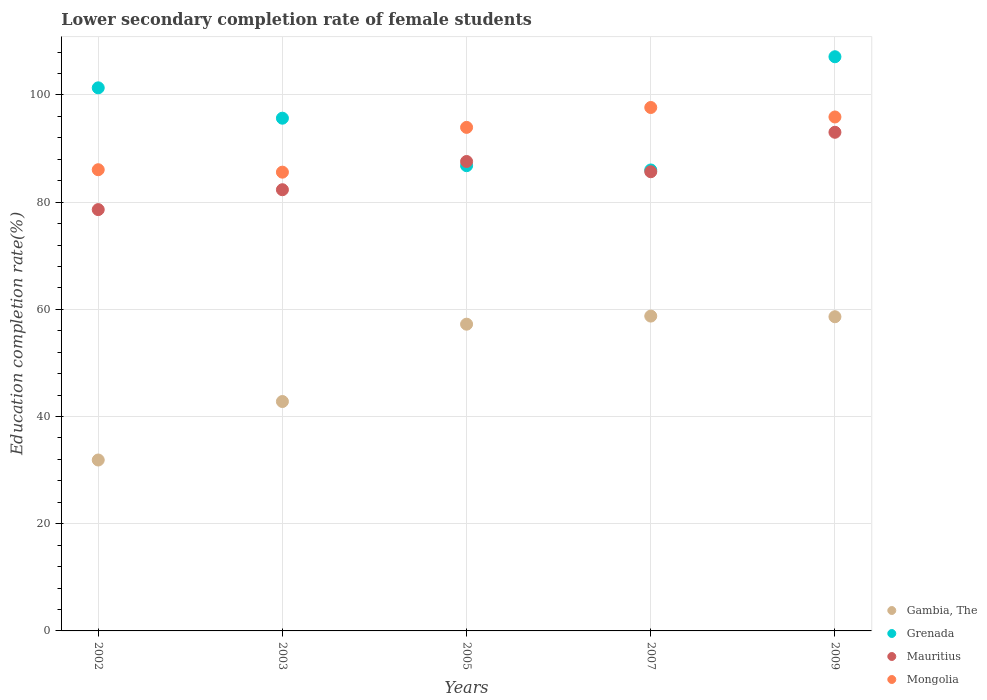How many different coloured dotlines are there?
Your answer should be compact. 4. What is the lower secondary completion rate of female students in Mongolia in 2009?
Your answer should be very brief. 95.9. Across all years, what is the maximum lower secondary completion rate of female students in Mongolia?
Offer a terse response. 97.67. Across all years, what is the minimum lower secondary completion rate of female students in Gambia, The?
Ensure brevity in your answer.  31.89. What is the total lower secondary completion rate of female students in Gambia, The in the graph?
Offer a terse response. 249.3. What is the difference between the lower secondary completion rate of female students in Gambia, The in 2002 and that in 2005?
Keep it short and to the point. -25.34. What is the difference between the lower secondary completion rate of female students in Mongolia in 2003 and the lower secondary completion rate of female students in Grenada in 2005?
Keep it short and to the point. -1.21. What is the average lower secondary completion rate of female students in Gambia, The per year?
Your answer should be very brief. 49.86. In the year 2005, what is the difference between the lower secondary completion rate of female students in Grenada and lower secondary completion rate of female students in Gambia, The?
Offer a terse response. 29.57. In how many years, is the lower secondary completion rate of female students in Grenada greater than 32 %?
Ensure brevity in your answer.  5. What is the ratio of the lower secondary completion rate of female students in Gambia, The in 2007 to that in 2009?
Your answer should be compact. 1. Is the lower secondary completion rate of female students in Mauritius in 2005 less than that in 2007?
Offer a terse response. No. Is the difference between the lower secondary completion rate of female students in Grenada in 2002 and 2005 greater than the difference between the lower secondary completion rate of female students in Gambia, The in 2002 and 2005?
Ensure brevity in your answer.  Yes. What is the difference between the highest and the second highest lower secondary completion rate of female students in Mongolia?
Offer a terse response. 1.77. What is the difference between the highest and the lowest lower secondary completion rate of female students in Mongolia?
Ensure brevity in your answer.  12.07. Is the sum of the lower secondary completion rate of female students in Grenada in 2003 and 2005 greater than the maximum lower secondary completion rate of female students in Gambia, The across all years?
Your answer should be very brief. Yes. Is it the case that in every year, the sum of the lower secondary completion rate of female students in Gambia, The and lower secondary completion rate of female students in Mauritius  is greater than the sum of lower secondary completion rate of female students in Mongolia and lower secondary completion rate of female students in Grenada?
Offer a terse response. Yes. Is it the case that in every year, the sum of the lower secondary completion rate of female students in Mongolia and lower secondary completion rate of female students in Mauritius  is greater than the lower secondary completion rate of female students in Grenada?
Provide a succinct answer. Yes. Does the lower secondary completion rate of female students in Mauritius monotonically increase over the years?
Your answer should be very brief. No. Is the lower secondary completion rate of female students in Grenada strictly greater than the lower secondary completion rate of female students in Mongolia over the years?
Ensure brevity in your answer.  No. How many dotlines are there?
Keep it short and to the point. 4. What is the difference between two consecutive major ticks on the Y-axis?
Your response must be concise. 20. Does the graph contain any zero values?
Offer a terse response. No. How many legend labels are there?
Keep it short and to the point. 4. What is the title of the graph?
Give a very brief answer. Lower secondary completion rate of female students. What is the label or title of the X-axis?
Keep it short and to the point. Years. What is the label or title of the Y-axis?
Give a very brief answer. Education completion rate(%). What is the Education completion rate(%) in Gambia, The in 2002?
Your answer should be very brief. 31.89. What is the Education completion rate(%) of Grenada in 2002?
Keep it short and to the point. 101.33. What is the Education completion rate(%) in Mauritius in 2002?
Provide a short and direct response. 78.61. What is the Education completion rate(%) of Mongolia in 2002?
Keep it short and to the point. 86.06. What is the Education completion rate(%) of Gambia, The in 2003?
Offer a terse response. 42.8. What is the Education completion rate(%) of Grenada in 2003?
Provide a succinct answer. 95.67. What is the Education completion rate(%) of Mauritius in 2003?
Offer a terse response. 82.32. What is the Education completion rate(%) of Mongolia in 2003?
Your answer should be very brief. 85.6. What is the Education completion rate(%) of Gambia, The in 2005?
Provide a short and direct response. 57.23. What is the Education completion rate(%) of Grenada in 2005?
Ensure brevity in your answer.  86.81. What is the Education completion rate(%) of Mauritius in 2005?
Offer a very short reply. 87.59. What is the Education completion rate(%) of Mongolia in 2005?
Your response must be concise. 93.96. What is the Education completion rate(%) in Gambia, The in 2007?
Your answer should be very brief. 58.74. What is the Education completion rate(%) of Grenada in 2007?
Give a very brief answer. 86.01. What is the Education completion rate(%) in Mauritius in 2007?
Keep it short and to the point. 85.68. What is the Education completion rate(%) in Mongolia in 2007?
Provide a succinct answer. 97.67. What is the Education completion rate(%) in Gambia, The in 2009?
Ensure brevity in your answer.  58.62. What is the Education completion rate(%) of Grenada in 2009?
Offer a very short reply. 107.14. What is the Education completion rate(%) of Mauritius in 2009?
Give a very brief answer. 93.04. What is the Education completion rate(%) in Mongolia in 2009?
Ensure brevity in your answer.  95.9. Across all years, what is the maximum Education completion rate(%) in Gambia, The?
Ensure brevity in your answer.  58.74. Across all years, what is the maximum Education completion rate(%) in Grenada?
Your answer should be compact. 107.14. Across all years, what is the maximum Education completion rate(%) in Mauritius?
Provide a short and direct response. 93.04. Across all years, what is the maximum Education completion rate(%) in Mongolia?
Offer a very short reply. 97.67. Across all years, what is the minimum Education completion rate(%) of Gambia, The?
Offer a very short reply. 31.89. Across all years, what is the minimum Education completion rate(%) of Grenada?
Offer a terse response. 86.01. Across all years, what is the minimum Education completion rate(%) in Mauritius?
Make the answer very short. 78.61. Across all years, what is the minimum Education completion rate(%) in Mongolia?
Ensure brevity in your answer.  85.6. What is the total Education completion rate(%) of Gambia, The in the graph?
Provide a short and direct response. 249.3. What is the total Education completion rate(%) of Grenada in the graph?
Ensure brevity in your answer.  476.95. What is the total Education completion rate(%) in Mauritius in the graph?
Provide a succinct answer. 427.25. What is the total Education completion rate(%) in Mongolia in the graph?
Provide a succinct answer. 459.17. What is the difference between the Education completion rate(%) of Gambia, The in 2002 and that in 2003?
Your answer should be compact. -10.91. What is the difference between the Education completion rate(%) in Grenada in 2002 and that in 2003?
Keep it short and to the point. 5.67. What is the difference between the Education completion rate(%) of Mauritius in 2002 and that in 2003?
Provide a succinct answer. -3.71. What is the difference between the Education completion rate(%) in Mongolia in 2002 and that in 2003?
Offer a terse response. 0.46. What is the difference between the Education completion rate(%) in Gambia, The in 2002 and that in 2005?
Provide a succinct answer. -25.34. What is the difference between the Education completion rate(%) in Grenada in 2002 and that in 2005?
Keep it short and to the point. 14.53. What is the difference between the Education completion rate(%) of Mauritius in 2002 and that in 2005?
Keep it short and to the point. -8.98. What is the difference between the Education completion rate(%) of Mongolia in 2002 and that in 2005?
Offer a very short reply. -7.9. What is the difference between the Education completion rate(%) in Gambia, The in 2002 and that in 2007?
Give a very brief answer. -26.85. What is the difference between the Education completion rate(%) in Grenada in 2002 and that in 2007?
Offer a very short reply. 15.33. What is the difference between the Education completion rate(%) in Mauritius in 2002 and that in 2007?
Keep it short and to the point. -7.07. What is the difference between the Education completion rate(%) of Mongolia in 2002 and that in 2007?
Keep it short and to the point. -11.61. What is the difference between the Education completion rate(%) in Gambia, The in 2002 and that in 2009?
Your response must be concise. -26.73. What is the difference between the Education completion rate(%) of Grenada in 2002 and that in 2009?
Your answer should be compact. -5.8. What is the difference between the Education completion rate(%) in Mauritius in 2002 and that in 2009?
Make the answer very short. -14.43. What is the difference between the Education completion rate(%) in Mongolia in 2002 and that in 2009?
Provide a short and direct response. -9.84. What is the difference between the Education completion rate(%) in Gambia, The in 2003 and that in 2005?
Your answer should be very brief. -14.43. What is the difference between the Education completion rate(%) of Grenada in 2003 and that in 2005?
Give a very brief answer. 8.86. What is the difference between the Education completion rate(%) of Mauritius in 2003 and that in 2005?
Your answer should be very brief. -5.27. What is the difference between the Education completion rate(%) in Mongolia in 2003 and that in 2005?
Keep it short and to the point. -8.36. What is the difference between the Education completion rate(%) in Gambia, The in 2003 and that in 2007?
Offer a very short reply. -15.94. What is the difference between the Education completion rate(%) in Grenada in 2003 and that in 2007?
Your response must be concise. 9.66. What is the difference between the Education completion rate(%) of Mauritius in 2003 and that in 2007?
Keep it short and to the point. -3.36. What is the difference between the Education completion rate(%) in Mongolia in 2003 and that in 2007?
Offer a very short reply. -12.07. What is the difference between the Education completion rate(%) in Gambia, The in 2003 and that in 2009?
Give a very brief answer. -15.82. What is the difference between the Education completion rate(%) in Grenada in 2003 and that in 2009?
Your answer should be very brief. -11.47. What is the difference between the Education completion rate(%) in Mauritius in 2003 and that in 2009?
Offer a terse response. -10.72. What is the difference between the Education completion rate(%) in Mongolia in 2003 and that in 2009?
Make the answer very short. -10.3. What is the difference between the Education completion rate(%) in Gambia, The in 2005 and that in 2007?
Give a very brief answer. -1.51. What is the difference between the Education completion rate(%) of Grenada in 2005 and that in 2007?
Ensure brevity in your answer.  0.8. What is the difference between the Education completion rate(%) in Mauritius in 2005 and that in 2007?
Offer a terse response. 1.91. What is the difference between the Education completion rate(%) in Mongolia in 2005 and that in 2007?
Make the answer very short. -3.71. What is the difference between the Education completion rate(%) of Gambia, The in 2005 and that in 2009?
Offer a terse response. -1.39. What is the difference between the Education completion rate(%) of Grenada in 2005 and that in 2009?
Your response must be concise. -20.33. What is the difference between the Education completion rate(%) in Mauritius in 2005 and that in 2009?
Ensure brevity in your answer.  -5.45. What is the difference between the Education completion rate(%) in Mongolia in 2005 and that in 2009?
Offer a very short reply. -1.94. What is the difference between the Education completion rate(%) of Gambia, The in 2007 and that in 2009?
Keep it short and to the point. 0.12. What is the difference between the Education completion rate(%) of Grenada in 2007 and that in 2009?
Give a very brief answer. -21.13. What is the difference between the Education completion rate(%) in Mauritius in 2007 and that in 2009?
Keep it short and to the point. -7.36. What is the difference between the Education completion rate(%) in Mongolia in 2007 and that in 2009?
Give a very brief answer. 1.77. What is the difference between the Education completion rate(%) of Gambia, The in 2002 and the Education completion rate(%) of Grenada in 2003?
Give a very brief answer. -63.78. What is the difference between the Education completion rate(%) of Gambia, The in 2002 and the Education completion rate(%) of Mauritius in 2003?
Provide a short and direct response. -50.43. What is the difference between the Education completion rate(%) in Gambia, The in 2002 and the Education completion rate(%) in Mongolia in 2003?
Give a very brief answer. -53.71. What is the difference between the Education completion rate(%) of Grenada in 2002 and the Education completion rate(%) of Mauritius in 2003?
Offer a terse response. 19.01. What is the difference between the Education completion rate(%) of Grenada in 2002 and the Education completion rate(%) of Mongolia in 2003?
Give a very brief answer. 15.74. What is the difference between the Education completion rate(%) of Mauritius in 2002 and the Education completion rate(%) of Mongolia in 2003?
Keep it short and to the point. -6.99. What is the difference between the Education completion rate(%) in Gambia, The in 2002 and the Education completion rate(%) in Grenada in 2005?
Provide a succinct answer. -54.92. What is the difference between the Education completion rate(%) in Gambia, The in 2002 and the Education completion rate(%) in Mauritius in 2005?
Offer a terse response. -55.7. What is the difference between the Education completion rate(%) of Gambia, The in 2002 and the Education completion rate(%) of Mongolia in 2005?
Offer a very short reply. -62.06. What is the difference between the Education completion rate(%) in Grenada in 2002 and the Education completion rate(%) in Mauritius in 2005?
Offer a very short reply. 13.74. What is the difference between the Education completion rate(%) in Grenada in 2002 and the Education completion rate(%) in Mongolia in 2005?
Provide a short and direct response. 7.38. What is the difference between the Education completion rate(%) in Mauritius in 2002 and the Education completion rate(%) in Mongolia in 2005?
Provide a short and direct response. -15.34. What is the difference between the Education completion rate(%) of Gambia, The in 2002 and the Education completion rate(%) of Grenada in 2007?
Ensure brevity in your answer.  -54.12. What is the difference between the Education completion rate(%) in Gambia, The in 2002 and the Education completion rate(%) in Mauritius in 2007?
Your response must be concise. -53.79. What is the difference between the Education completion rate(%) of Gambia, The in 2002 and the Education completion rate(%) of Mongolia in 2007?
Keep it short and to the point. -65.77. What is the difference between the Education completion rate(%) of Grenada in 2002 and the Education completion rate(%) of Mauritius in 2007?
Offer a very short reply. 15.65. What is the difference between the Education completion rate(%) in Grenada in 2002 and the Education completion rate(%) in Mongolia in 2007?
Keep it short and to the point. 3.67. What is the difference between the Education completion rate(%) of Mauritius in 2002 and the Education completion rate(%) of Mongolia in 2007?
Your answer should be compact. -19.05. What is the difference between the Education completion rate(%) in Gambia, The in 2002 and the Education completion rate(%) in Grenada in 2009?
Give a very brief answer. -75.24. What is the difference between the Education completion rate(%) of Gambia, The in 2002 and the Education completion rate(%) of Mauritius in 2009?
Keep it short and to the point. -61.15. What is the difference between the Education completion rate(%) of Gambia, The in 2002 and the Education completion rate(%) of Mongolia in 2009?
Give a very brief answer. -64.01. What is the difference between the Education completion rate(%) of Grenada in 2002 and the Education completion rate(%) of Mauritius in 2009?
Make the answer very short. 8.29. What is the difference between the Education completion rate(%) of Grenada in 2002 and the Education completion rate(%) of Mongolia in 2009?
Offer a terse response. 5.44. What is the difference between the Education completion rate(%) in Mauritius in 2002 and the Education completion rate(%) in Mongolia in 2009?
Make the answer very short. -17.28. What is the difference between the Education completion rate(%) in Gambia, The in 2003 and the Education completion rate(%) in Grenada in 2005?
Provide a succinct answer. -44. What is the difference between the Education completion rate(%) in Gambia, The in 2003 and the Education completion rate(%) in Mauritius in 2005?
Your response must be concise. -44.79. What is the difference between the Education completion rate(%) in Gambia, The in 2003 and the Education completion rate(%) in Mongolia in 2005?
Your answer should be very brief. -51.15. What is the difference between the Education completion rate(%) in Grenada in 2003 and the Education completion rate(%) in Mauritius in 2005?
Offer a very short reply. 8.08. What is the difference between the Education completion rate(%) in Grenada in 2003 and the Education completion rate(%) in Mongolia in 2005?
Provide a succinct answer. 1.71. What is the difference between the Education completion rate(%) of Mauritius in 2003 and the Education completion rate(%) of Mongolia in 2005?
Give a very brief answer. -11.63. What is the difference between the Education completion rate(%) of Gambia, The in 2003 and the Education completion rate(%) of Grenada in 2007?
Keep it short and to the point. -43.21. What is the difference between the Education completion rate(%) of Gambia, The in 2003 and the Education completion rate(%) of Mauritius in 2007?
Keep it short and to the point. -42.88. What is the difference between the Education completion rate(%) of Gambia, The in 2003 and the Education completion rate(%) of Mongolia in 2007?
Ensure brevity in your answer.  -54.86. What is the difference between the Education completion rate(%) of Grenada in 2003 and the Education completion rate(%) of Mauritius in 2007?
Offer a very short reply. 9.99. What is the difference between the Education completion rate(%) of Grenada in 2003 and the Education completion rate(%) of Mongolia in 2007?
Offer a terse response. -2. What is the difference between the Education completion rate(%) of Mauritius in 2003 and the Education completion rate(%) of Mongolia in 2007?
Keep it short and to the point. -15.34. What is the difference between the Education completion rate(%) of Gambia, The in 2003 and the Education completion rate(%) of Grenada in 2009?
Provide a short and direct response. -64.33. What is the difference between the Education completion rate(%) in Gambia, The in 2003 and the Education completion rate(%) in Mauritius in 2009?
Offer a very short reply. -50.24. What is the difference between the Education completion rate(%) in Gambia, The in 2003 and the Education completion rate(%) in Mongolia in 2009?
Provide a short and direct response. -53.09. What is the difference between the Education completion rate(%) in Grenada in 2003 and the Education completion rate(%) in Mauritius in 2009?
Your answer should be compact. 2.63. What is the difference between the Education completion rate(%) of Grenada in 2003 and the Education completion rate(%) of Mongolia in 2009?
Your answer should be very brief. -0.23. What is the difference between the Education completion rate(%) in Mauritius in 2003 and the Education completion rate(%) in Mongolia in 2009?
Keep it short and to the point. -13.57. What is the difference between the Education completion rate(%) of Gambia, The in 2005 and the Education completion rate(%) of Grenada in 2007?
Your answer should be compact. -28.78. What is the difference between the Education completion rate(%) of Gambia, The in 2005 and the Education completion rate(%) of Mauritius in 2007?
Keep it short and to the point. -28.45. What is the difference between the Education completion rate(%) of Gambia, The in 2005 and the Education completion rate(%) of Mongolia in 2007?
Make the answer very short. -40.43. What is the difference between the Education completion rate(%) of Grenada in 2005 and the Education completion rate(%) of Mauritius in 2007?
Give a very brief answer. 1.13. What is the difference between the Education completion rate(%) of Grenada in 2005 and the Education completion rate(%) of Mongolia in 2007?
Make the answer very short. -10.86. What is the difference between the Education completion rate(%) of Mauritius in 2005 and the Education completion rate(%) of Mongolia in 2007?
Provide a succinct answer. -10.07. What is the difference between the Education completion rate(%) of Gambia, The in 2005 and the Education completion rate(%) of Grenada in 2009?
Your answer should be compact. -49.9. What is the difference between the Education completion rate(%) of Gambia, The in 2005 and the Education completion rate(%) of Mauritius in 2009?
Your response must be concise. -35.81. What is the difference between the Education completion rate(%) of Gambia, The in 2005 and the Education completion rate(%) of Mongolia in 2009?
Your answer should be compact. -38.66. What is the difference between the Education completion rate(%) in Grenada in 2005 and the Education completion rate(%) in Mauritius in 2009?
Offer a terse response. -6.24. What is the difference between the Education completion rate(%) of Grenada in 2005 and the Education completion rate(%) of Mongolia in 2009?
Offer a terse response. -9.09. What is the difference between the Education completion rate(%) in Mauritius in 2005 and the Education completion rate(%) in Mongolia in 2009?
Give a very brief answer. -8.31. What is the difference between the Education completion rate(%) in Gambia, The in 2007 and the Education completion rate(%) in Grenada in 2009?
Keep it short and to the point. -48.39. What is the difference between the Education completion rate(%) in Gambia, The in 2007 and the Education completion rate(%) in Mauritius in 2009?
Your answer should be very brief. -34.3. What is the difference between the Education completion rate(%) in Gambia, The in 2007 and the Education completion rate(%) in Mongolia in 2009?
Make the answer very short. -37.15. What is the difference between the Education completion rate(%) in Grenada in 2007 and the Education completion rate(%) in Mauritius in 2009?
Offer a terse response. -7.03. What is the difference between the Education completion rate(%) in Grenada in 2007 and the Education completion rate(%) in Mongolia in 2009?
Your answer should be compact. -9.89. What is the difference between the Education completion rate(%) of Mauritius in 2007 and the Education completion rate(%) of Mongolia in 2009?
Offer a terse response. -10.22. What is the average Education completion rate(%) of Gambia, The per year?
Offer a very short reply. 49.86. What is the average Education completion rate(%) in Grenada per year?
Ensure brevity in your answer.  95.39. What is the average Education completion rate(%) of Mauritius per year?
Provide a succinct answer. 85.45. What is the average Education completion rate(%) in Mongolia per year?
Offer a terse response. 91.83. In the year 2002, what is the difference between the Education completion rate(%) in Gambia, The and Education completion rate(%) in Grenada?
Make the answer very short. -69.44. In the year 2002, what is the difference between the Education completion rate(%) of Gambia, The and Education completion rate(%) of Mauritius?
Provide a succinct answer. -46.72. In the year 2002, what is the difference between the Education completion rate(%) of Gambia, The and Education completion rate(%) of Mongolia?
Your response must be concise. -54.16. In the year 2002, what is the difference between the Education completion rate(%) in Grenada and Education completion rate(%) in Mauritius?
Offer a very short reply. 22.72. In the year 2002, what is the difference between the Education completion rate(%) in Grenada and Education completion rate(%) in Mongolia?
Provide a short and direct response. 15.28. In the year 2002, what is the difference between the Education completion rate(%) in Mauritius and Education completion rate(%) in Mongolia?
Keep it short and to the point. -7.44. In the year 2003, what is the difference between the Education completion rate(%) in Gambia, The and Education completion rate(%) in Grenada?
Ensure brevity in your answer.  -52.86. In the year 2003, what is the difference between the Education completion rate(%) of Gambia, The and Education completion rate(%) of Mauritius?
Provide a short and direct response. -39.52. In the year 2003, what is the difference between the Education completion rate(%) in Gambia, The and Education completion rate(%) in Mongolia?
Your answer should be compact. -42.8. In the year 2003, what is the difference between the Education completion rate(%) in Grenada and Education completion rate(%) in Mauritius?
Offer a terse response. 13.35. In the year 2003, what is the difference between the Education completion rate(%) of Grenada and Education completion rate(%) of Mongolia?
Offer a terse response. 10.07. In the year 2003, what is the difference between the Education completion rate(%) of Mauritius and Education completion rate(%) of Mongolia?
Your answer should be compact. -3.28. In the year 2005, what is the difference between the Education completion rate(%) of Gambia, The and Education completion rate(%) of Grenada?
Make the answer very short. -29.57. In the year 2005, what is the difference between the Education completion rate(%) of Gambia, The and Education completion rate(%) of Mauritius?
Offer a very short reply. -30.36. In the year 2005, what is the difference between the Education completion rate(%) of Gambia, The and Education completion rate(%) of Mongolia?
Give a very brief answer. -36.72. In the year 2005, what is the difference between the Education completion rate(%) in Grenada and Education completion rate(%) in Mauritius?
Give a very brief answer. -0.78. In the year 2005, what is the difference between the Education completion rate(%) in Grenada and Education completion rate(%) in Mongolia?
Ensure brevity in your answer.  -7.15. In the year 2005, what is the difference between the Education completion rate(%) of Mauritius and Education completion rate(%) of Mongolia?
Give a very brief answer. -6.37. In the year 2007, what is the difference between the Education completion rate(%) in Gambia, The and Education completion rate(%) in Grenada?
Provide a succinct answer. -27.26. In the year 2007, what is the difference between the Education completion rate(%) in Gambia, The and Education completion rate(%) in Mauritius?
Keep it short and to the point. -26.94. In the year 2007, what is the difference between the Education completion rate(%) in Gambia, The and Education completion rate(%) in Mongolia?
Give a very brief answer. -38.92. In the year 2007, what is the difference between the Education completion rate(%) of Grenada and Education completion rate(%) of Mauritius?
Give a very brief answer. 0.33. In the year 2007, what is the difference between the Education completion rate(%) of Grenada and Education completion rate(%) of Mongolia?
Your answer should be very brief. -11.66. In the year 2007, what is the difference between the Education completion rate(%) of Mauritius and Education completion rate(%) of Mongolia?
Provide a succinct answer. -11.99. In the year 2009, what is the difference between the Education completion rate(%) in Gambia, The and Education completion rate(%) in Grenada?
Your answer should be very brief. -48.51. In the year 2009, what is the difference between the Education completion rate(%) in Gambia, The and Education completion rate(%) in Mauritius?
Your answer should be very brief. -34.42. In the year 2009, what is the difference between the Education completion rate(%) in Gambia, The and Education completion rate(%) in Mongolia?
Your answer should be compact. -37.27. In the year 2009, what is the difference between the Education completion rate(%) of Grenada and Education completion rate(%) of Mauritius?
Offer a very short reply. 14.09. In the year 2009, what is the difference between the Education completion rate(%) in Grenada and Education completion rate(%) in Mongolia?
Make the answer very short. 11.24. In the year 2009, what is the difference between the Education completion rate(%) of Mauritius and Education completion rate(%) of Mongolia?
Make the answer very short. -2.85. What is the ratio of the Education completion rate(%) in Gambia, The in 2002 to that in 2003?
Keep it short and to the point. 0.75. What is the ratio of the Education completion rate(%) of Grenada in 2002 to that in 2003?
Your response must be concise. 1.06. What is the ratio of the Education completion rate(%) of Mauritius in 2002 to that in 2003?
Offer a very short reply. 0.95. What is the ratio of the Education completion rate(%) of Gambia, The in 2002 to that in 2005?
Give a very brief answer. 0.56. What is the ratio of the Education completion rate(%) of Grenada in 2002 to that in 2005?
Your response must be concise. 1.17. What is the ratio of the Education completion rate(%) in Mauritius in 2002 to that in 2005?
Your answer should be very brief. 0.9. What is the ratio of the Education completion rate(%) in Mongolia in 2002 to that in 2005?
Make the answer very short. 0.92. What is the ratio of the Education completion rate(%) in Gambia, The in 2002 to that in 2007?
Keep it short and to the point. 0.54. What is the ratio of the Education completion rate(%) in Grenada in 2002 to that in 2007?
Ensure brevity in your answer.  1.18. What is the ratio of the Education completion rate(%) in Mauritius in 2002 to that in 2007?
Your answer should be very brief. 0.92. What is the ratio of the Education completion rate(%) of Mongolia in 2002 to that in 2007?
Provide a short and direct response. 0.88. What is the ratio of the Education completion rate(%) in Gambia, The in 2002 to that in 2009?
Your answer should be very brief. 0.54. What is the ratio of the Education completion rate(%) of Grenada in 2002 to that in 2009?
Keep it short and to the point. 0.95. What is the ratio of the Education completion rate(%) of Mauritius in 2002 to that in 2009?
Make the answer very short. 0.84. What is the ratio of the Education completion rate(%) of Mongolia in 2002 to that in 2009?
Your answer should be very brief. 0.9. What is the ratio of the Education completion rate(%) in Gambia, The in 2003 to that in 2005?
Your answer should be very brief. 0.75. What is the ratio of the Education completion rate(%) in Grenada in 2003 to that in 2005?
Offer a terse response. 1.1. What is the ratio of the Education completion rate(%) in Mauritius in 2003 to that in 2005?
Provide a short and direct response. 0.94. What is the ratio of the Education completion rate(%) in Mongolia in 2003 to that in 2005?
Provide a short and direct response. 0.91. What is the ratio of the Education completion rate(%) in Gambia, The in 2003 to that in 2007?
Keep it short and to the point. 0.73. What is the ratio of the Education completion rate(%) of Grenada in 2003 to that in 2007?
Provide a short and direct response. 1.11. What is the ratio of the Education completion rate(%) in Mauritius in 2003 to that in 2007?
Offer a terse response. 0.96. What is the ratio of the Education completion rate(%) in Mongolia in 2003 to that in 2007?
Offer a very short reply. 0.88. What is the ratio of the Education completion rate(%) in Gambia, The in 2003 to that in 2009?
Your response must be concise. 0.73. What is the ratio of the Education completion rate(%) of Grenada in 2003 to that in 2009?
Offer a terse response. 0.89. What is the ratio of the Education completion rate(%) of Mauritius in 2003 to that in 2009?
Offer a terse response. 0.88. What is the ratio of the Education completion rate(%) of Mongolia in 2003 to that in 2009?
Your response must be concise. 0.89. What is the ratio of the Education completion rate(%) in Gambia, The in 2005 to that in 2007?
Provide a short and direct response. 0.97. What is the ratio of the Education completion rate(%) in Grenada in 2005 to that in 2007?
Your answer should be very brief. 1.01. What is the ratio of the Education completion rate(%) of Mauritius in 2005 to that in 2007?
Your response must be concise. 1.02. What is the ratio of the Education completion rate(%) in Mongolia in 2005 to that in 2007?
Provide a short and direct response. 0.96. What is the ratio of the Education completion rate(%) in Gambia, The in 2005 to that in 2009?
Your answer should be compact. 0.98. What is the ratio of the Education completion rate(%) of Grenada in 2005 to that in 2009?
Your answer should be compact. 0.81. What is the ratio of the Education completion rate(%) of Mauritius in 2005 to that in 2009?
Your answer should be compact. 0.94. What is the ratio of the Education completion rate(%) of Mongolia in 2005 to that in 2009?
Your answer should be compact. 0.98. What is the ratio of the Education completion rate(%) in Grenada in 2007 to that in 2009?
Keep it short and to the point. 0.8. What is the ratio of the Education completion rate(%) of Mauritius in 2007 to that in 2009?
Give a very brief answer. 0.92. What is the ratio of the Education completion rate(%) of Mongolia in 2007 to that in 2009?
Provide a succinct answer. 1.02. What is the difference between the highest and the second highest Education completion rate(%) in Gambia, The?
Provide a succinct answer. 0.12. What is the difference between the highest and the second highest Education completion rate(%) of Grenada?
Keep it short and to the point. 5.8. What is the difference between the highest and the second highest Education completion rate(%) in Mauritius?
Keep it short and to the point. 5.45. What is the difference between the highest and the second highest Education completion rate(%) in Mongolia?
Your answer should be very brief. 1.77. What is the difference between the highest and the lowest Education completion rate(%) of Gambia, The?
Your answer should be compact. 26.85. What is the difference between the highest and the lowest Education completion rate(%) of Grenada?
Your answer should be very brief. 21.13. What is the difference between the highest and the lowest Education completion rate(%) in Mauritius?
Offer a terse response. 14.43. What is the difference between the highest and the lowest Education completion rate(%) in Mongolia?
Give a very brief answer. 12.07. 